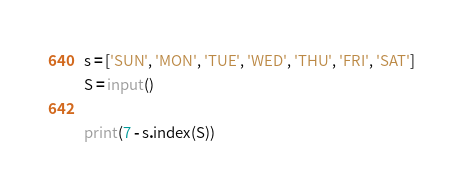<code> <loc_0><loc_0><loc_500><loc_500><_Python_>s = ['SUN', 'MON', 'TUE', 'WED', 'THU', 'FRI', 'SAT']
S = input()

print(7 - s.index(S))</code> 